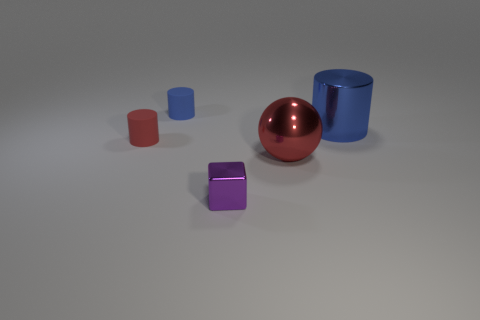Is there any pattern or symmetry in how the objects are arranged? The objects are arranged with no precise pattern or symmetry; they are placed at varying distances and angles relative to each other. 